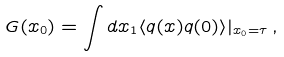<formula> <loc_0><loc_0><loc_500><loc_500>G ( x _ { 0 } ) = \int d x _ { 1 } \langle q ( x ) q ( 0 ) \rangle | _ { x _ { 0 } = \tau } \, ,</formula> 